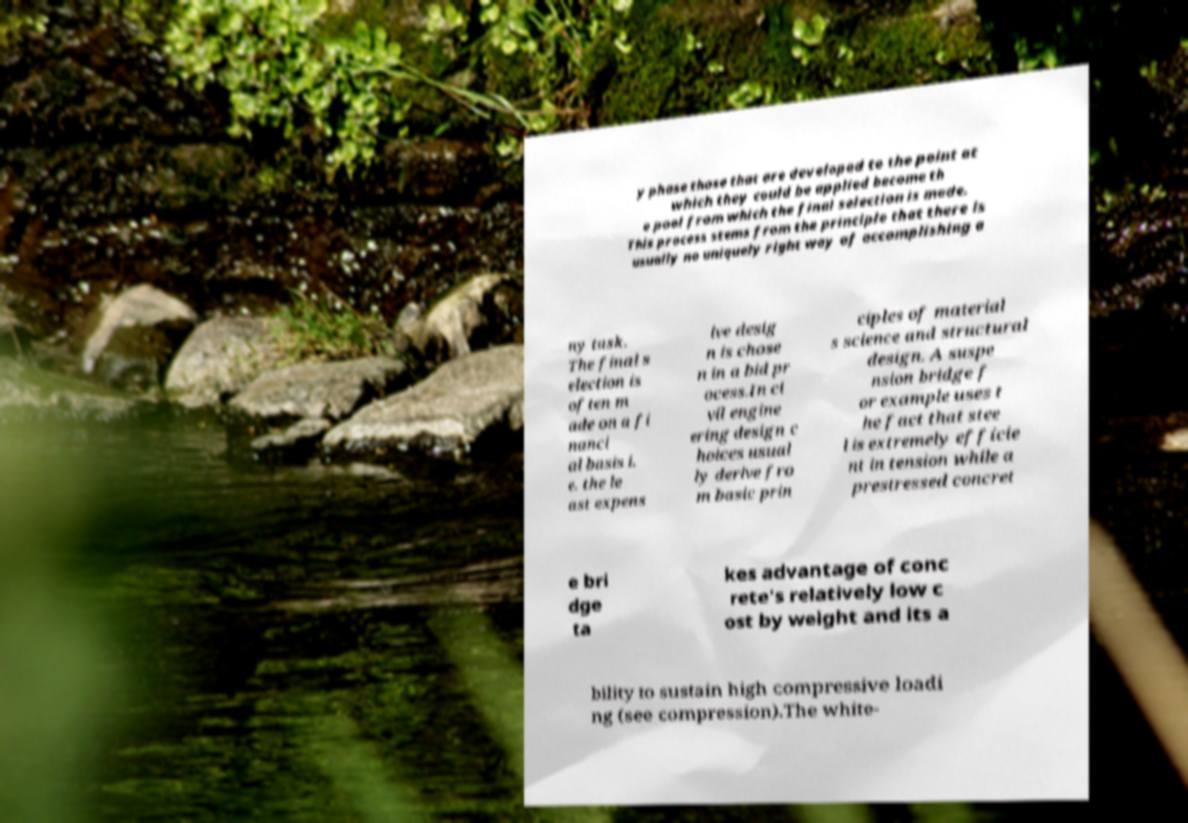For documentation purposes, I need the text within this image transcribed. Could you provide that? y phase those that are developed to the point at which they could be applied become th e pool from which the final selection is made. This process stems from the principle that there is usually no uniquely right way of accomplishing a ny task. The final s election is often m ade on a fi nanci al basis i. e. the le ast expens ive desig n is chose n in a bid pr ocess.In ci vil engine ering design c hoices usual ly derive fro m basic prin ciples of material s science and structural design. A suspe nsion bridge f or example uses t he fact that stee l is extremely efficie nt in tension while a prestressed concret e bri dge ta kes advantage of conc rete's relatively low c ost by weight and its a bility to sustain high compressive loadi ng (see compression).The white- 